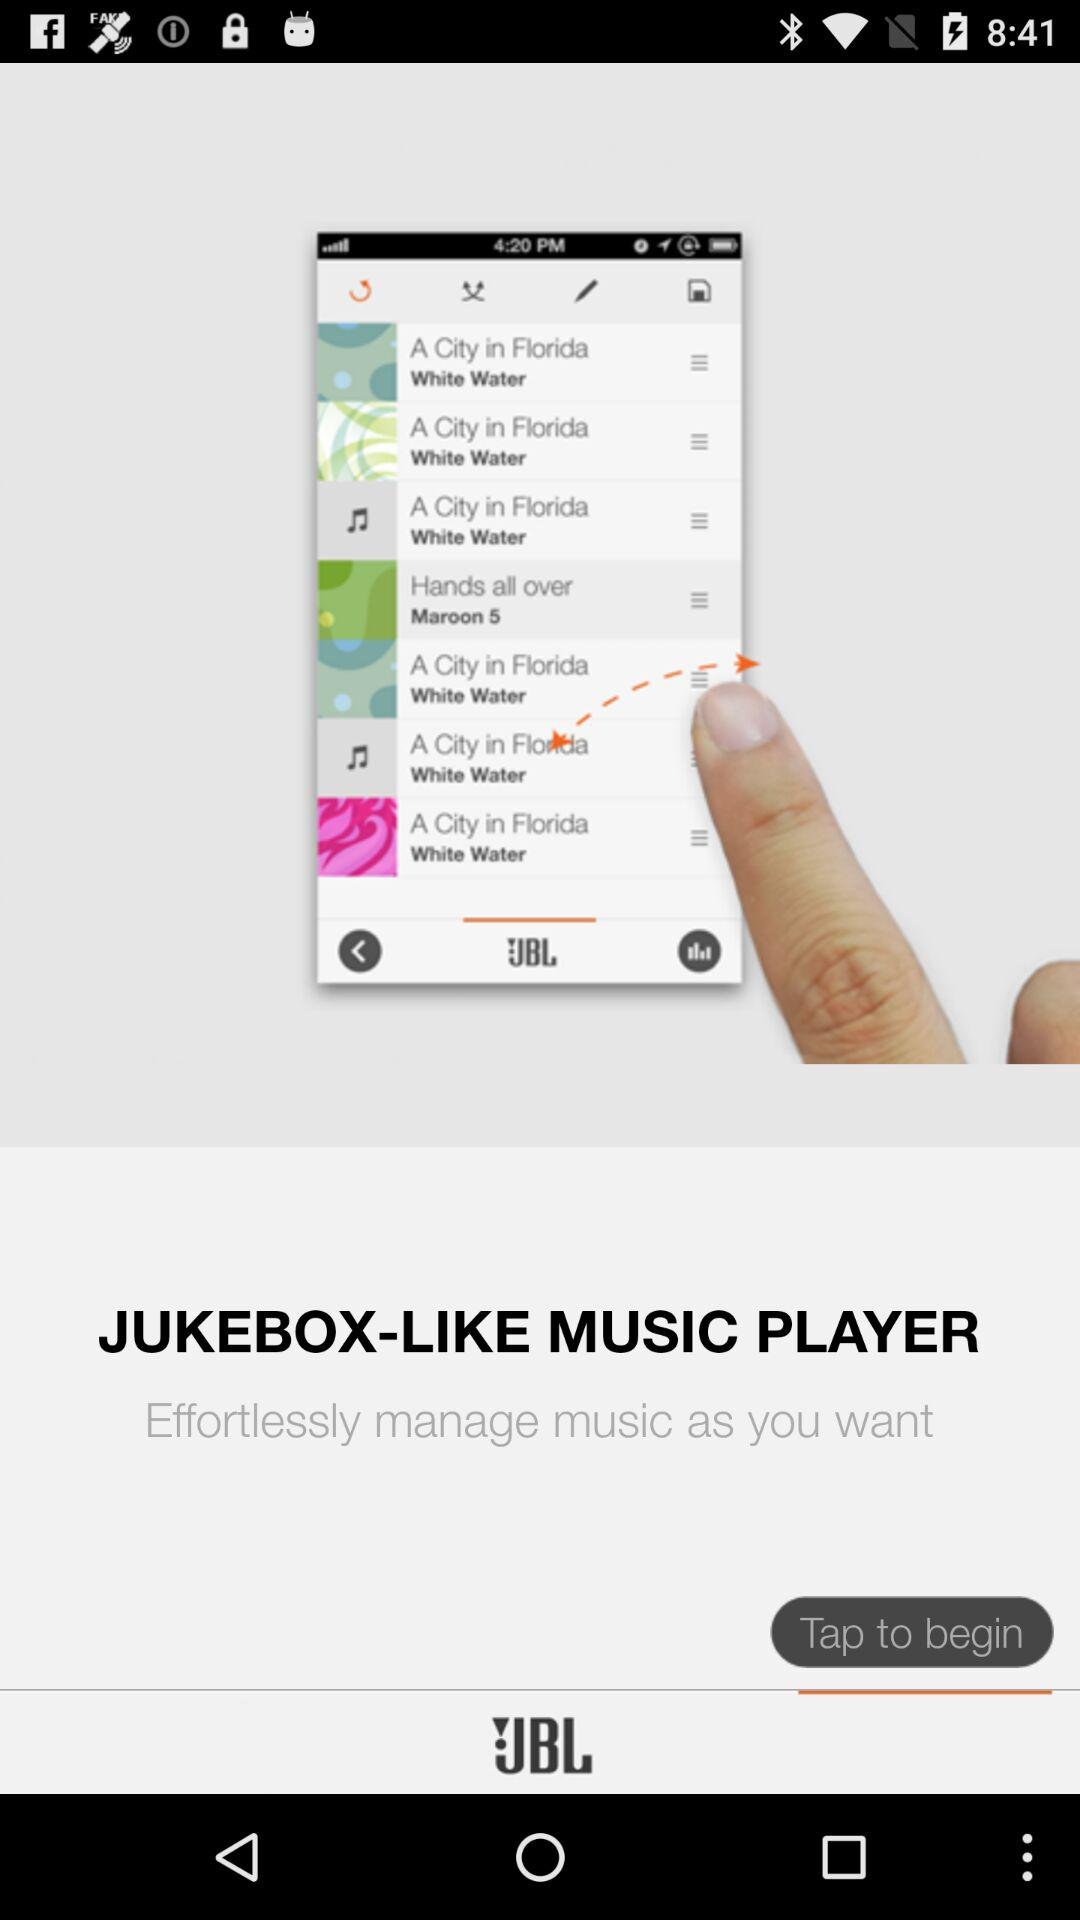What is the application name? The application name is "JBL Music". 